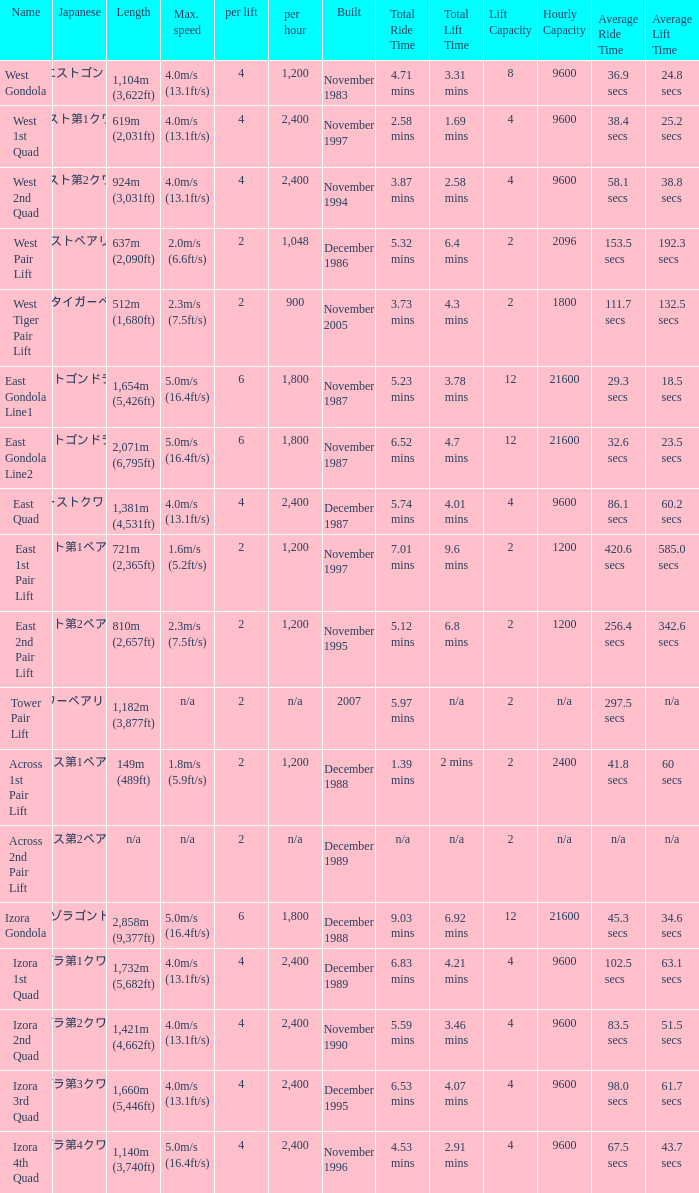How heavy is the  maximum 6.0. 